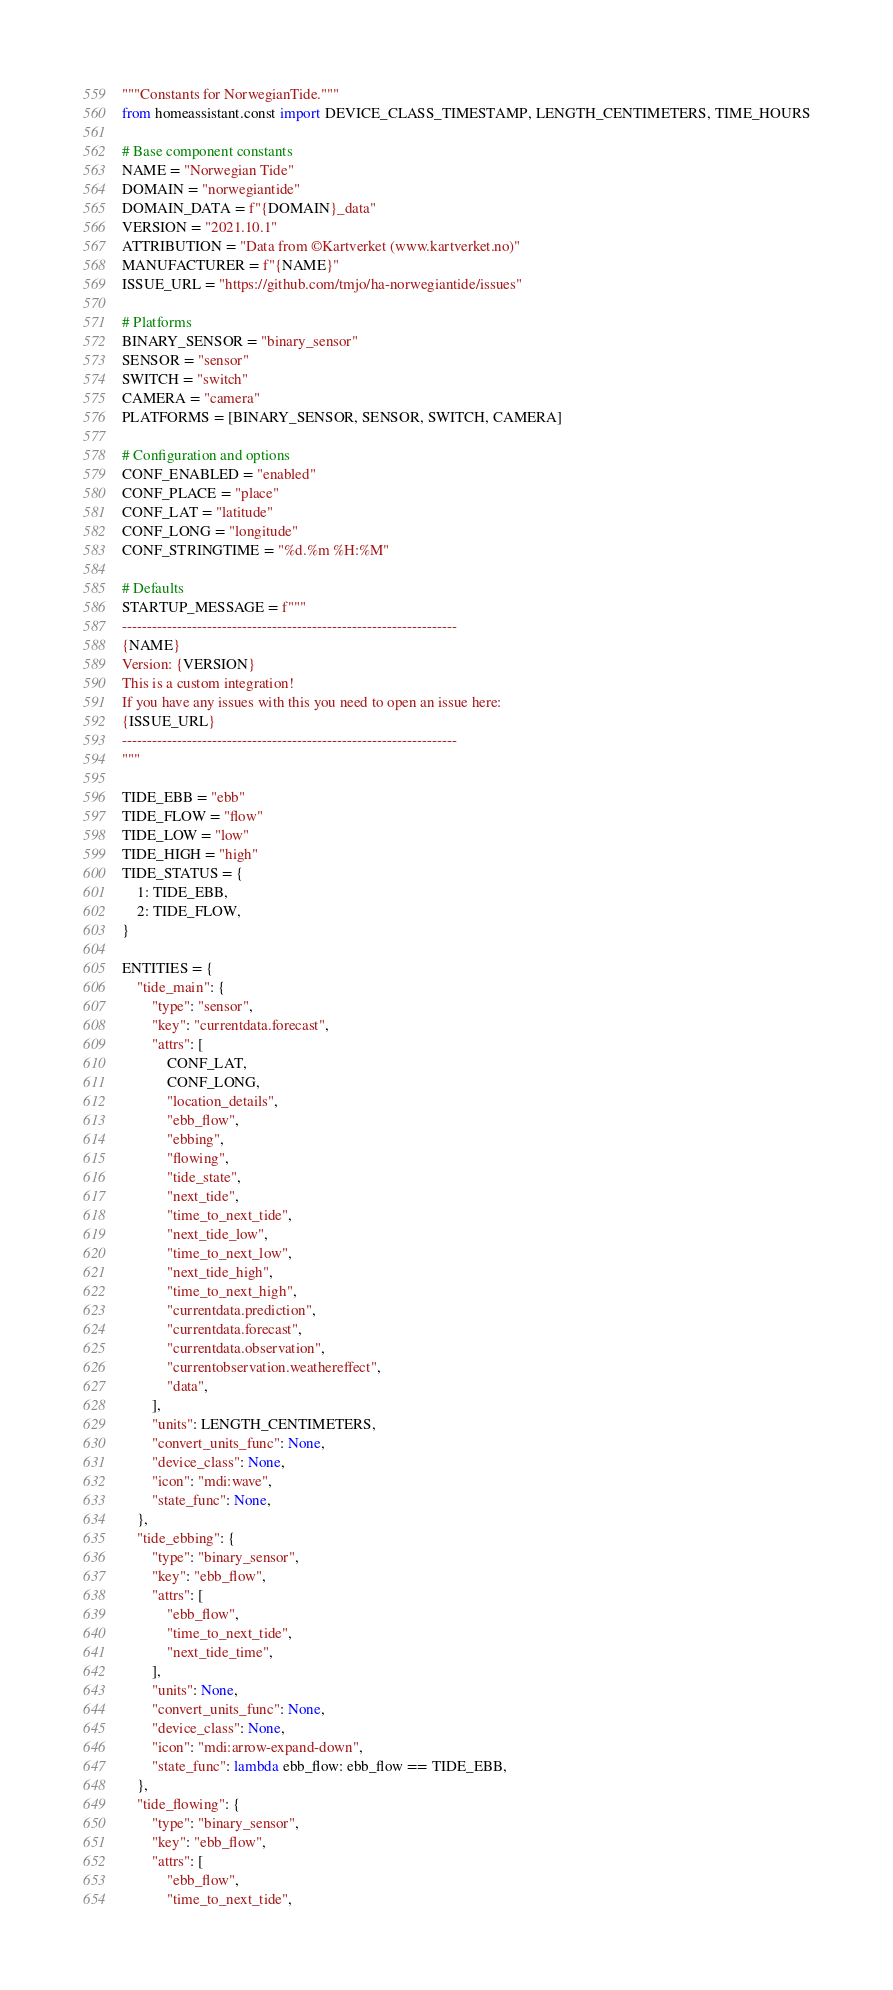<code> <loc_0><loc_0><loc_500><loc_500><_Python_>"""Constants for NorwegianTide."""
from homeassistant.const import DEVICE_CLASS_TIMESTAMP, LENGTH_CENTIMETERS, TIME_HOURS

# Base component constants
NAME = "Norwegian Tide"
DOMAIN = "norwegiantide"
DOMAIN_DATA = f"{DOMAIN}_data"
VERSION = "2021.10.1"
ATTRIBUTION = "Data from ©Kartverket (www.kartverket.no)"
MANUFACTURER = f"{NAME}"
ISSUE_URL = "https://github.com/tmjo/ha-norwegiantide/issues"

# Platforms
BINARY_SENSOR = "binary_sensor"
SENSOR = "sensor"
SWITCH = "switch"
CAMERA = "camera"
PLATFORMS = [BINARY_SENSOR, SENSOR, SWITCH, CAMERA]

# Configuration and options
CONF_ENABLED = "enabled"
CONF_PLACE = "place"
CONF_LAT = "latitude"
CONF_LONG = "longitude"
CONF_STRINGTIME = "%d.%m %H:%M"

# Defaults
STARTUP_MESSAGE = f"""
-------------------------------------------------------------------
{NAME}
Version: {VERSION}
This is a custom integration!
If you have any issues with this you need to open an issue here:
{ISSUE_URL}
-------------------------------------------------------------------
"""

TIDE_EBB = "ebb"
TIDE_FLOW = "flow"
TIDE_LOW = "low"
TIDE_HIGH = "high"
TIDE_STATUS = {
    1: TIDE_EBB,
    2: TIDE_FLOW,
}

ENTITIES = {
    "tide_main": {
        "type": "sensor",
        "key": "currentdata.forecast",
        "attrs": [
            CONF_LAT,
            CONF_LONG,
            "location_details",
            "ebb_flow",
            "ebbing",
            "flowing",
            "tide_state",
            "next_tide",
            "time_to_next_tide",
            "next_tide_low",
            "time_to_next_low",
            "next_tide_high",
            "time_to_next_high",
            "currentdata.prediction",
            "currentdata.forecast",
            "currentdata.observation",
            "currentobservation.weathereffect",
            "data",
        ],
        "units": LENGTH_CENTIMETERS,
        "convert_units_func": None,
        "device_class": None,
        "icon": "mdi:wave",
        "state_func": None,
    },
    "tide_ebbing": {
        "type": "binary_sensor",
        "key": "ebb_flow",
        "attrs": [
            "ebb_flow",
            "time_to_next_tide",
            "next_tide_time",
        ],
        "units": None,
        "convert_units_func": None,
        "device_class": None,
        "icon": "mdi:arrow-expand-down",
        "state_func": lambda ebb_flow: ebb_flow == TIDE_EBB,
    },
    "tide_flowing": {
        "type": "binary_sensor",
        "key": "ebb_flow",
        "attrs": [
            "ebb_flow",
            "time_to_next_tide",</code> 